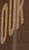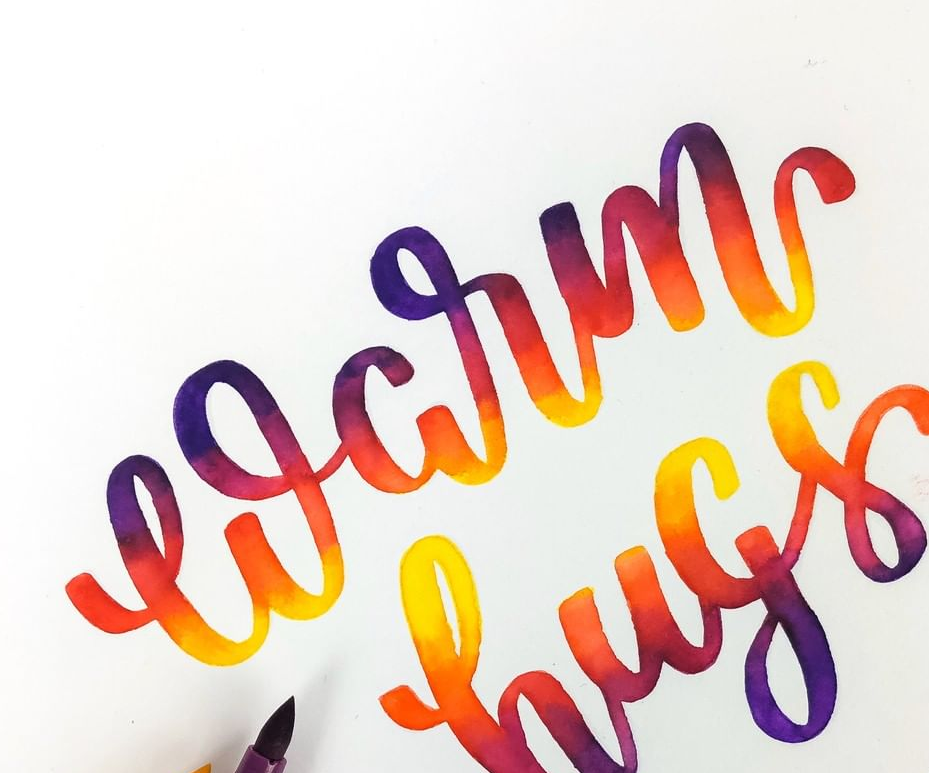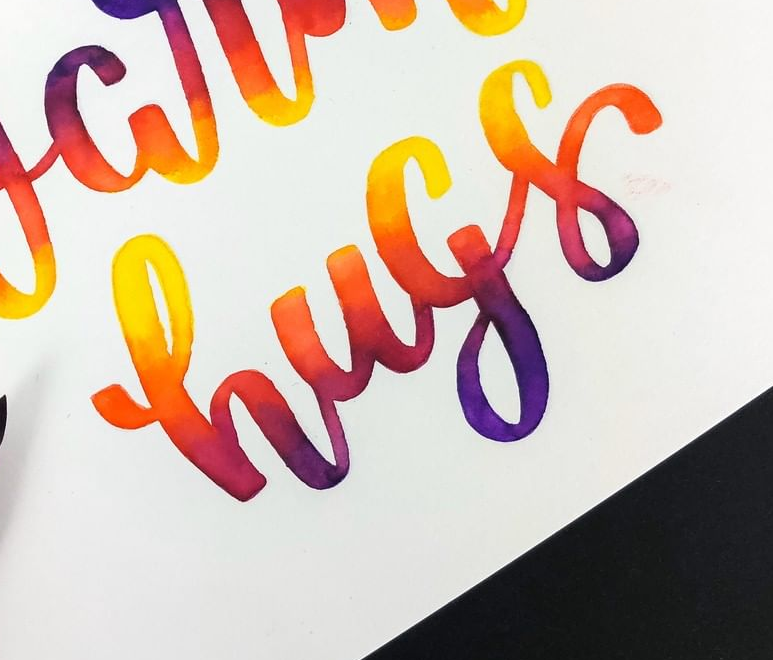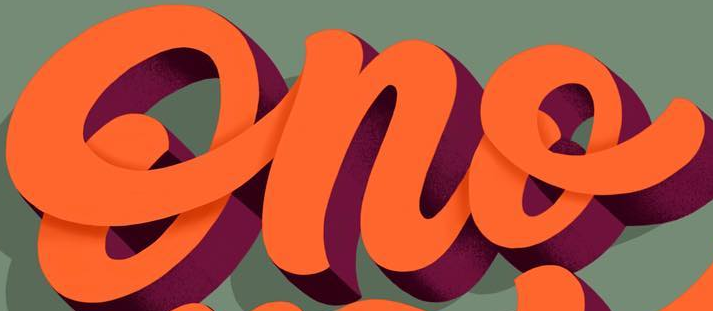What text appears in these images from left to right, separated by a semicolon? OUK; warm; hugs; Ono 